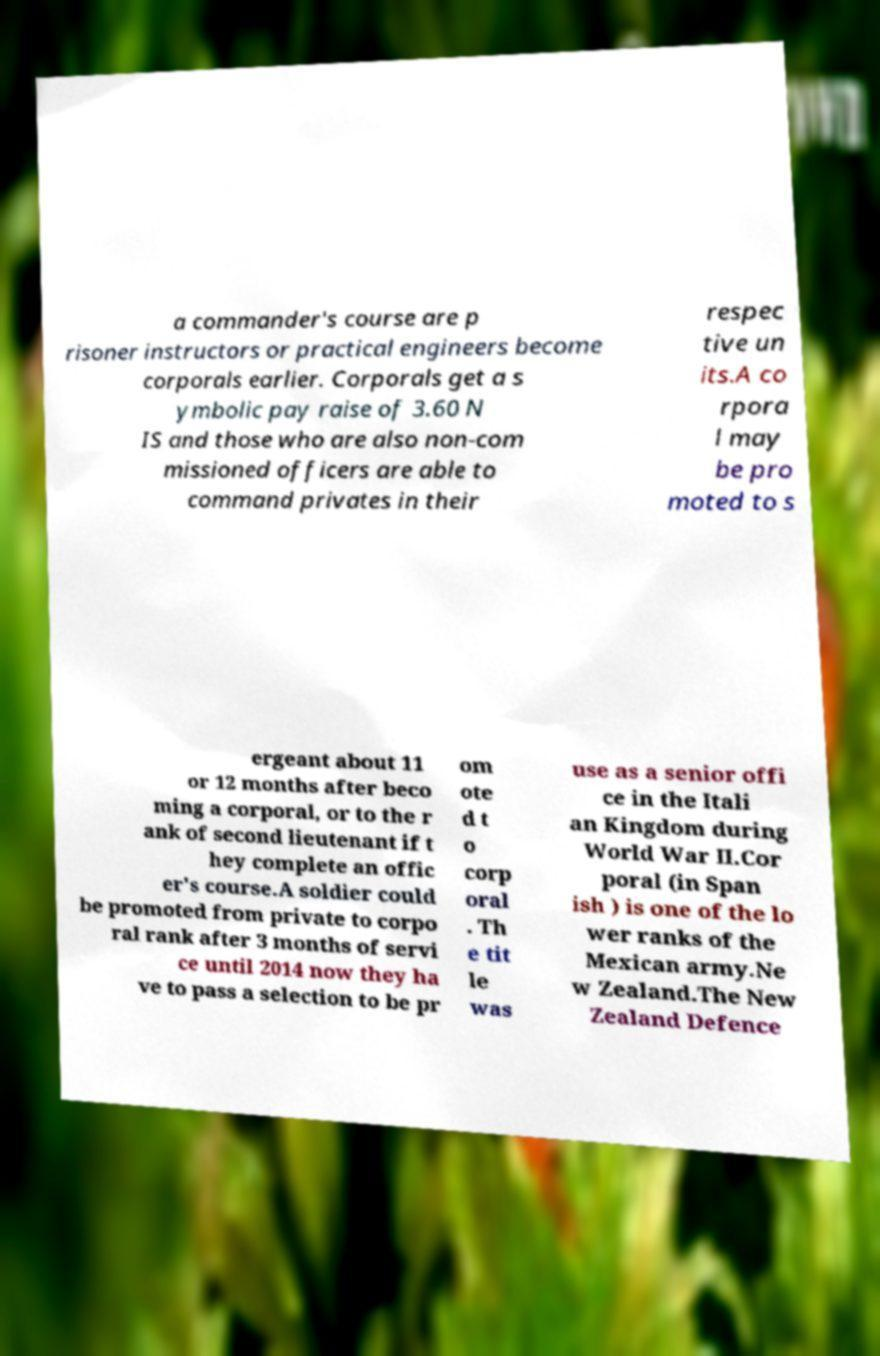Can you accurately transcribe the text from the provided image for me? a commander's course are p risoner instructors or practical engineers become corporals earlier. Corporals get a s ymbolic pay raise of 3.60 N IS and those who are also non-com missioned officers are able to command privates in their respec tive un its.A co rpora l may be pro moted to s ergeant about 11 or 12 months after beco ming a corporal, or to the r ank of second lieutenant if t hey complete an offic er's course.A soldier could be promoted from private to corpo ral rank after 3 months of servi ce until 2014 now they ha ve to pass a selection to be pr om ote d t o corp oral . Th e tit le was use as a senior offi ce in the Itali an Kingdom during World War II.Cor poral (in Span ish ) is one of the lo wer ranks of the Mexican army.Ne w Zealand.The New Zealand Defence 